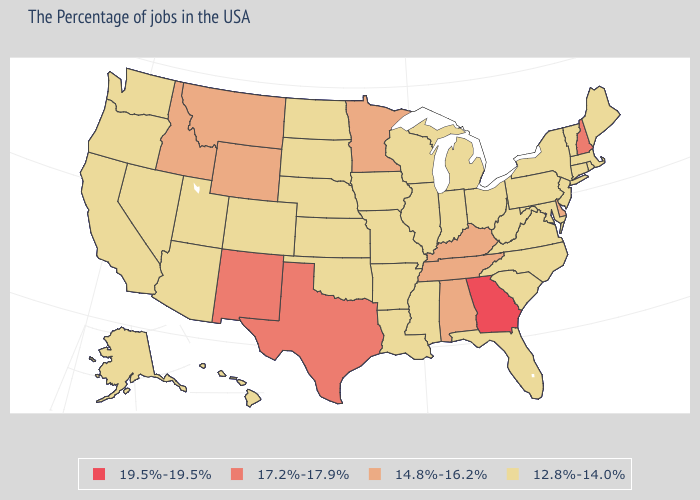Name the states that have a value in the range 17.2%-17.9%?
Write a very short answer. New Hampshire, Texas, New Mexico. Name the states that have a value in the range 17.2%-17.9%?
Write a very short answer. New Hampshire, Texas, New Mexico. What is the value of Alaska?
Write a very short answer. 12.8%-14.0%. Does the first symbol in the legend represent the smallest category?
Write a very short answer. No. Which states have the lowest value in the Northeast?
Write a very short answer. Maine, Massachusetts, Rhode Island, Vermont, Connecticut, New York, New Jersey, Pennsylvania. Which states have the lowest value in the USA?
Write a very short answer. Maine, Massachusetts, Rhode Island, Vermont, Connecticut, New York, New Jersey, Maryland, Pennsylvania, Virginia, North Carolina, South Carolina, West Virginia, Ohio, Florida, Michigan, Indiana, Wisconsin, Illinois, Mississippi, Louisiana, Missouri, Arkansas, Iowa, Kansas, Nebraska, Oklahoma, South Dakota, North Dakota, Colorado, Utah, Arizona, Nevada, California, Washington, Oregon, Alaska, Hawaii. Name the states that have a value in the range 17.2%-17.9%?
Concise answer only. New Hampshire, Texas, New Mexico. What is the highest value in states that border Maryland?
Keep it brief. 14.8%-16.2%. What is the highest value in the USA?
Keep it brief. 19.5%-19.5%. What is the lowest value in the West?
Concise answer only. 12.8%-14.0%. Does Wisconsin have the same value as West Virginia?
Keep it brief. Yes. Which states have the lowest value in the USA?
Answer briefly. Maine, Massachusetts, Rhode Island, Vermont, Connecticut, New York, New Jersey, Maryland, Pennsylvania, Virginia, North Carolina, South Carolina, West Virginia, Ohio, Florida, Michigan, Indiana, Wisconsin, Illinois, Mississippi, Louisiana, Missouri, Arkansas, Iowa, Kansas, Nebraska, Oklahoma, South Dakota, North Dakota, Colorado, Utah, Arizona, Nevada, California, Washington, Oregon, Alaska, Hawaii. Name the states that have a value in the range 17.2%-17.9%?
Keep it brief. New Hampshire, Texas, New Mexico. Among the states that border Tennessee , does Kentucky have the lowest value?
Write a very short answer. No. 